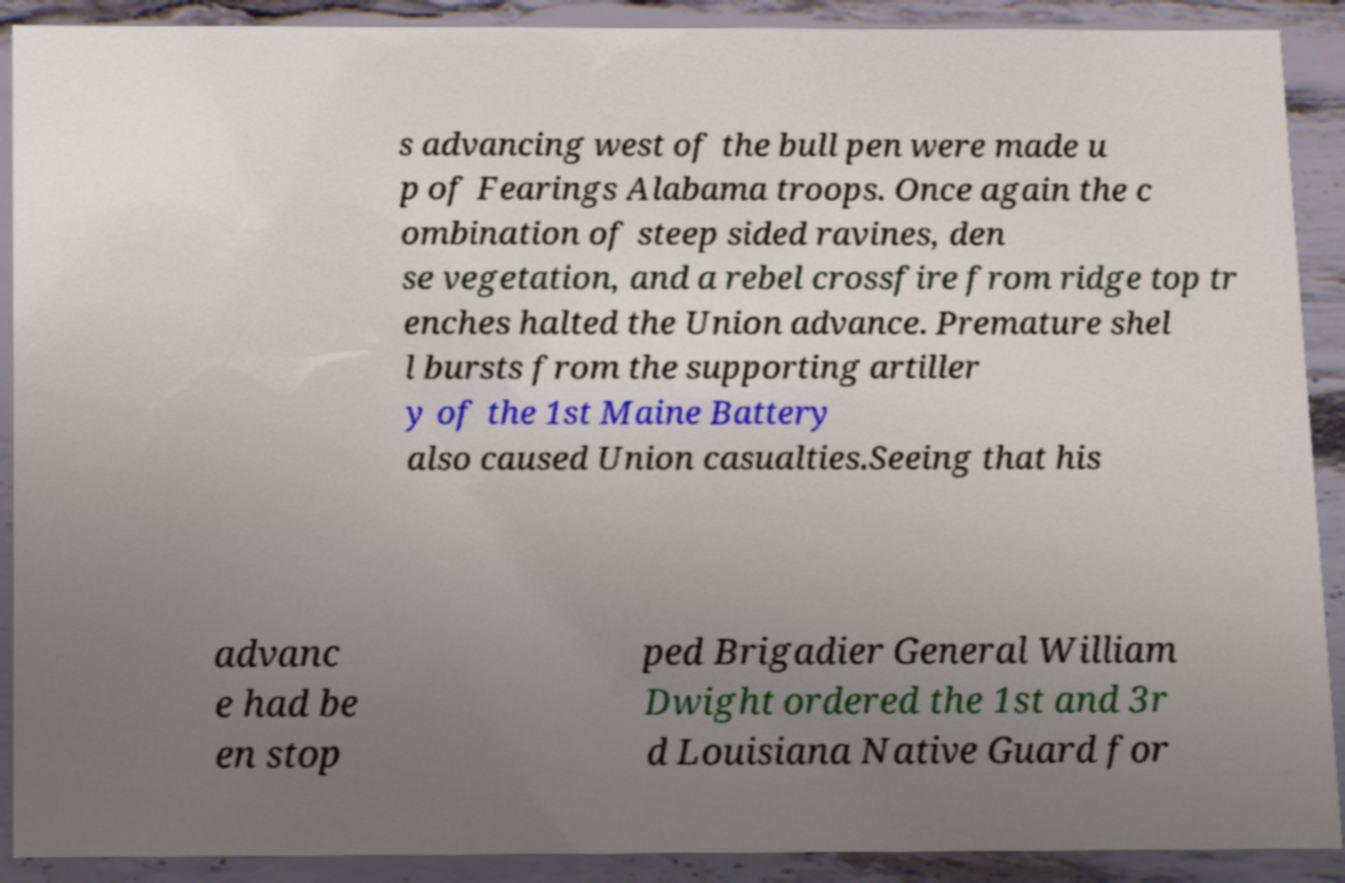Could you extract and type out the text from this image? s advancing west of the bull pen were made u p of Fearings Alabama troops. Once again the c ombination of steep sided ravines, den se vegetation, and a rebel crossfire from ridge top tr enches halted the Union advance. Premature shel l bursts from the supporting artiller y of the 1st Maine Battery also caused Union casualties.Seeing that his advanc e had be en stop ped Brigadier General William Dwight ordered the 1st and 3r d Louisiana Native Guard for 